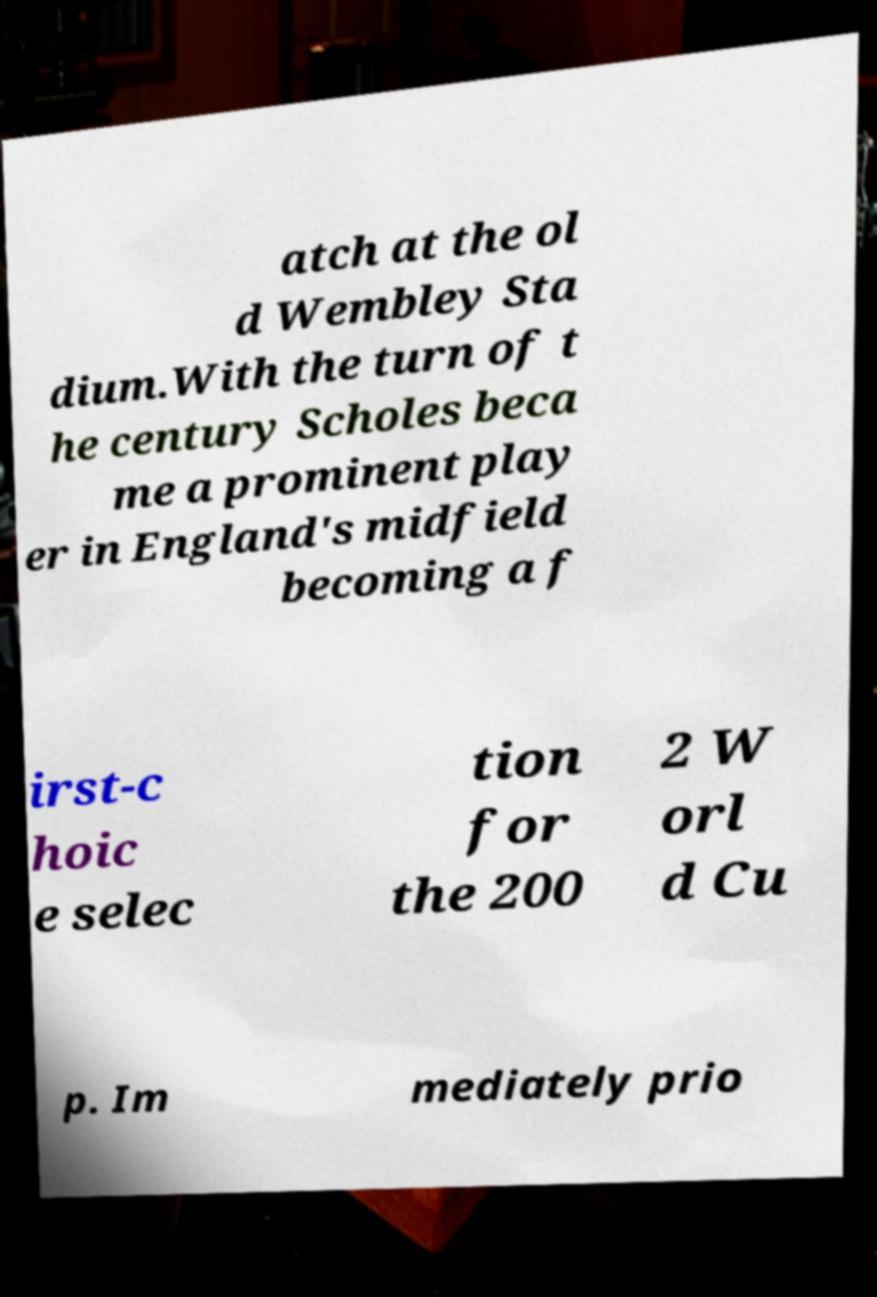Please read and relay the text visible in this image. What does it say? atch at the ol d Wembley Sta dium.With the turn of t he century Scholes beca me a prominent play er in England's midfield becoming a f irst-c hoic e selec tion for the 200 2 W orl d Cu p. Im mediately prio 